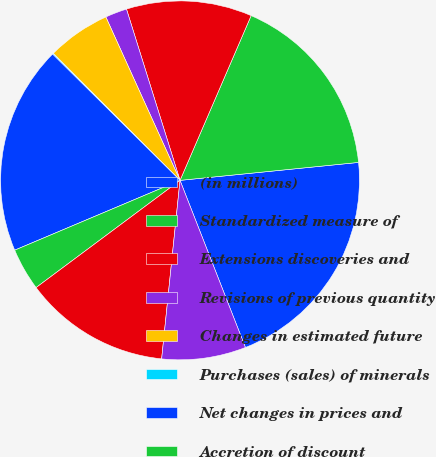Convert chart to OTSL. <chart><loc_0><loc_0><loc_500><loc_500><pie_chart><fcel>(in millions)<fcel>Standardized measure of<fcel>Extensions discoveries and<fcel>Revisions of previous quantity<fcel>Changes in estimated future<fcel>Purchases (sales) of minerals<fcel>Net changes in prices and<fcel>Accretion of discount<fcel>Sales of oil and gas produced<fcel>Development costs incurred<nl><fcel>20.66%<fcel>16.92%<fcel>11.31%<fcel>1.96%<fcel>5.7%<fcel>0.09%<fcel>18.79%<fcel>3.83%<fcel>13.18%<fcel>7.57%<nl></chart> 